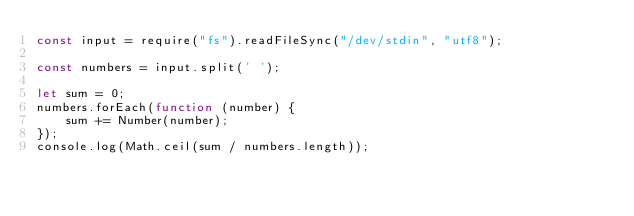<code> <loc_0><loc_0><loc_500><loc_500><_JavaScript_>const input = require("fs").readFileSync("/dev/stdin", "utf8");

const numbers = input.split(' ');

let sum = 0;
numbers.forEach(function (number) {
    sum += Number(number);
});
console.log(Math.ceil(sum / numbers.length));
</code> 